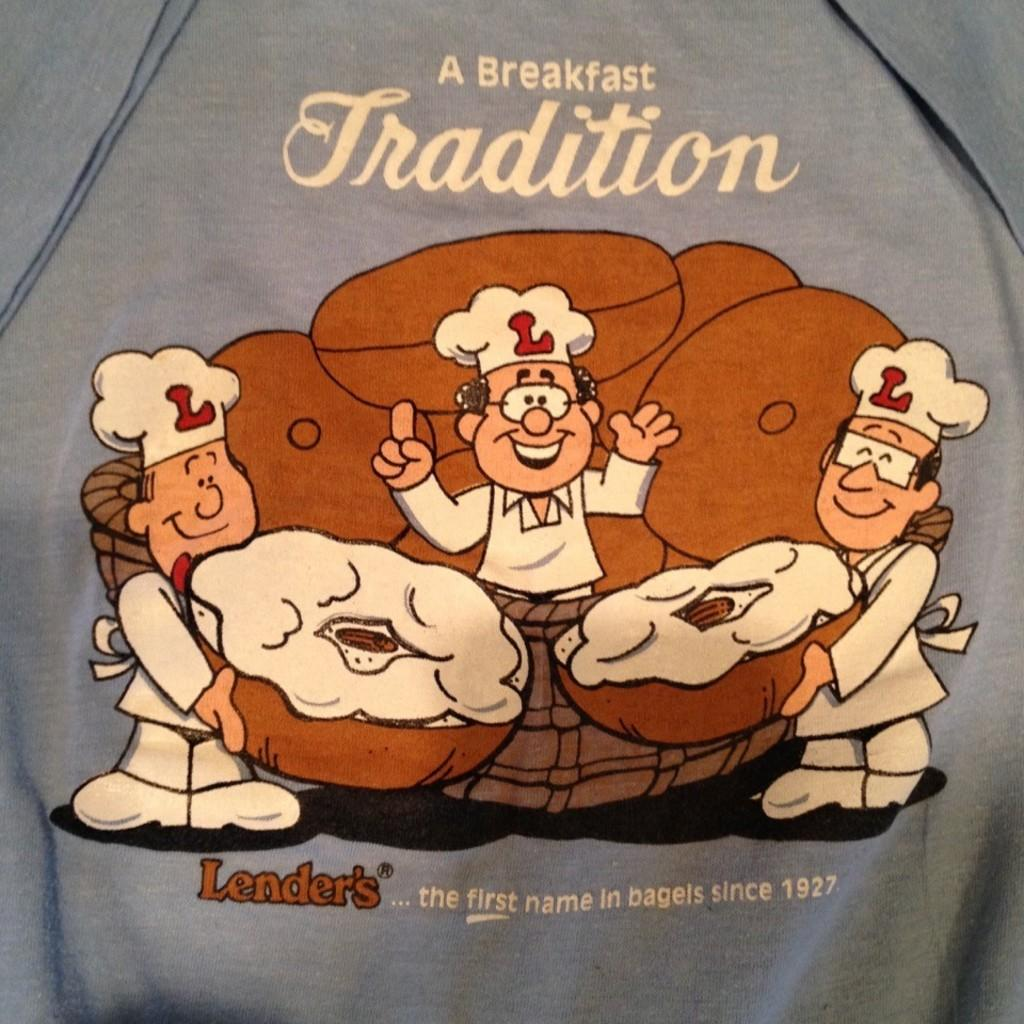What type of characters are depicted in the image? There is a cartoon image of chefs in the image. What are the chefs holding in their hands? The chefs are holding donuts. Can you describe any text or writing in the image? There is writing on a cloth in the image. What type of fairies can be seen flying around the chefs in the image? There are no fairies present in the image; it only features cartoon chefs holding donuts and writing on a cloth. 